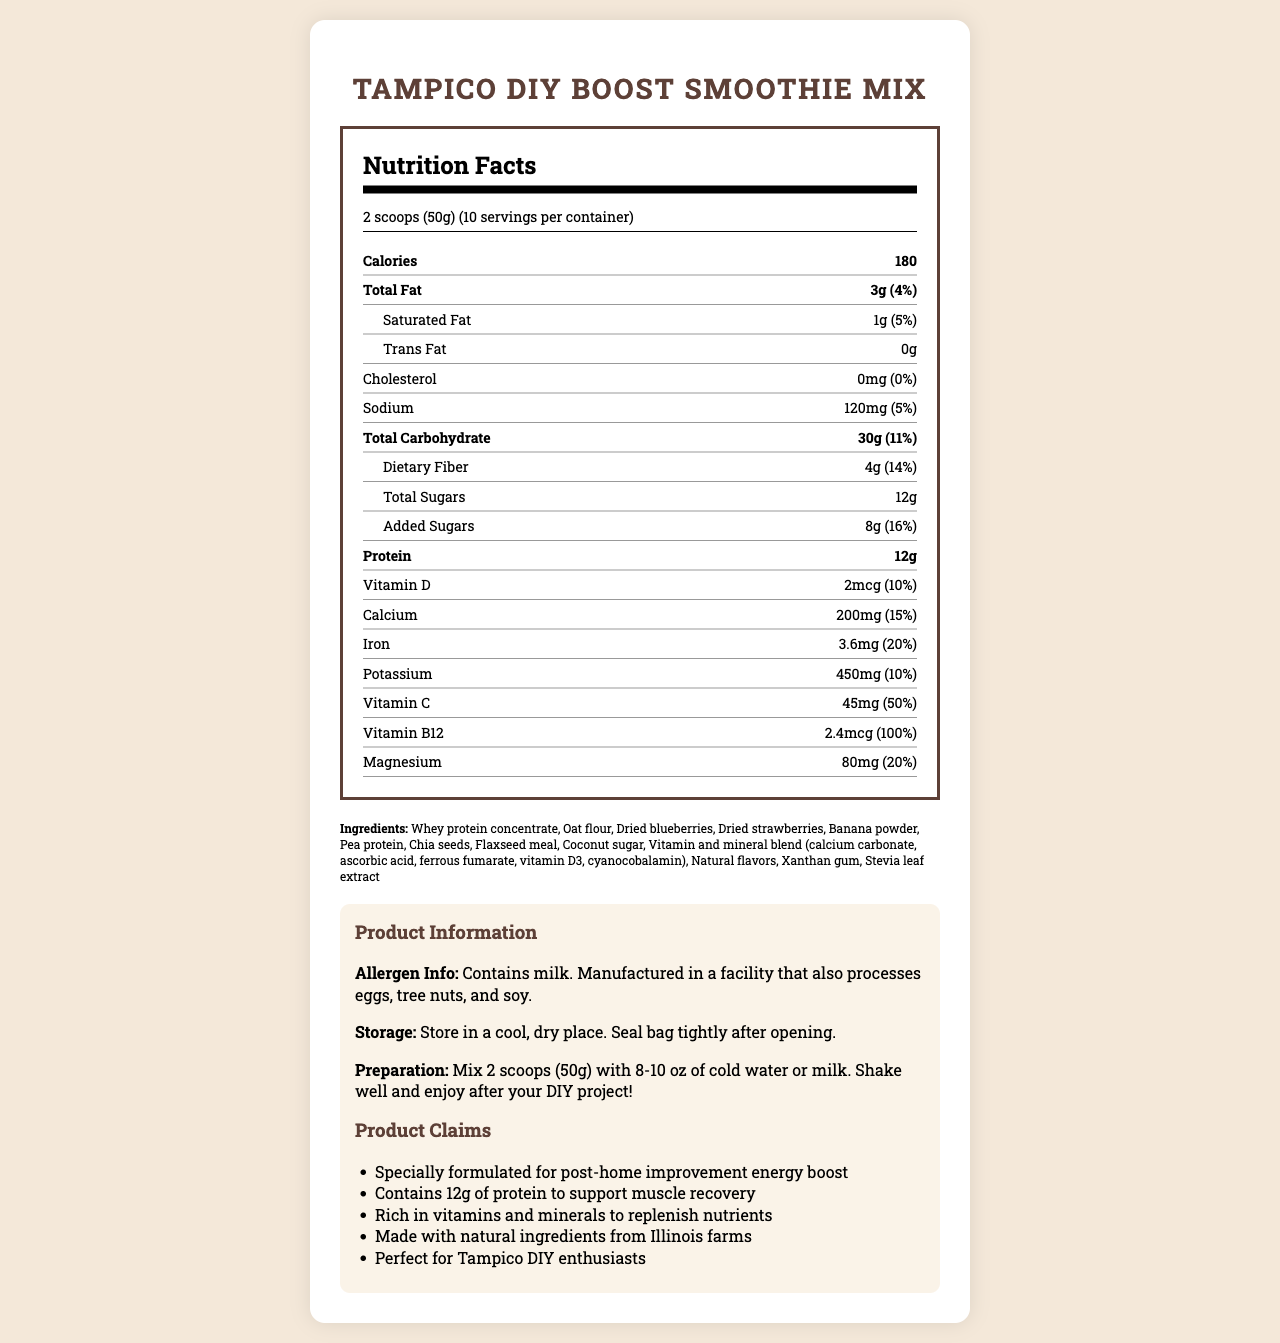what is the serving size for the Tampico DIY Boost Smoothie Mix? The serving size is explicitly stated in the document as "2 scoops (50g)."
Answer: 2 scoops (50g) how many servings are in one container of the smoothie mix? The document mentions that each container has 10 servings.
Answer: 10 how many calories are in one serving? Under the nutrition facts, it states that there are 180 calories per serving.
Answer: 180 what is the amount of protein per serving? The document shows that each serving contains 12 grams of protein.
Answer: 12g how much total fat is in one serving? The amount of total fat per serving is listed as 3 grams.
Answer: 3g how much added sugar is in each serving? The nutrition label indicates that there are 8 grams of added sugars per serving.
Answer: 8g Is there any trans fat in the Tampico DIY Boost Smoothie Mix? The document specifies that it contains 0 grams of trans fat.
Answer: No what are the main ingredients in the smoothie mix? A list of ingredients is provided in the document under the "ingredients" section.
Answer: Whey protein concentrate, Oat flour, Dried blueberries, Dried strawberries, Banana powder, Pea protein, Chia seeds, Flaxseed meal, Coconut sugar, Vitamin and mineral blend, Natural flavors, Xanthan gum, Stevia leaf extract what is the daily value percentage of Iron per serving? The nutrition facts label shows that each serving provides 20% of the daily value for Iron.
Answer: 20% for post-DIY project recovery, why is this smoothie mix beneficial? A. It contains high amounts of sugars B. It's low in calories C. It has 12g of protein to support muscle recovery D. It's rich in trans fat The document mentions that the product contains 12 grams of protein to support muscle recovery, which is beneficial for post-DIY project recovery.
Answer: C which of the following is NOT listed as a product claim for the smoothie mix? I. Made with natural ingredients from Illinois farms II. Contains 10g of fiber III. Perfect for Tampico DIY enthusiasts The document does not indicate that the product contains 10g of fiber, making option II incorrect.
Answer: II. Contains 10g of fiber is this smoothie mix suitable for people with milk allergies? The allergen information states that the product contains milk, making it unsuitable for those with milk allergies.
Answer: No summarize the main idea of the document. The document comprehensively describes the nutritional value, ingredients, and benefits of the Tampico DIY Boost Smoothie Mix, aimed at providing a post-home improvement energy boost and muscle recovery support, along with storage and preparation guidelines.
Answer: This document provides detailed nutritional information, ingredients, allergen info, storage instructions, preparation instructions, and product claims for the Tampico DIY Boost Smoothie Mix. It highlights the mix's suitability for an energy boost after DIY projects, emphasizing its protein content to support muscle recovery and rich nutrient profile. how much Vitamin B12 does each serving contain? The nutrition label indicates each serving contains 2.4 micrograms of Vitamin B12.
Answer: 2.4mcg what percentage of daily value does Vitamin C contribute? According to the nutrition facts, Vitamin C contributes 50% of the daily value per serving.
Answer: 50% where are the natural ingredients in the smoothie mix sourced from? The document specifies that the product is made with natural ingredients from Illinois farms but does not provide specific sourcing details.
Answer: Cannot be determined 